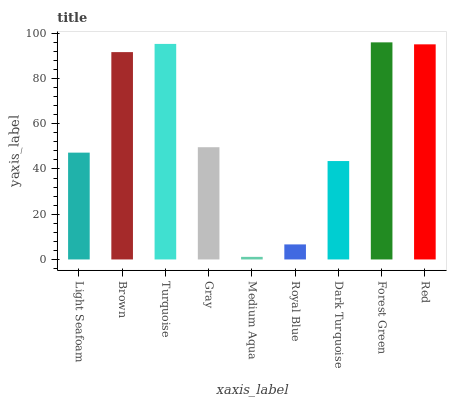Is Medium Aqua the minimum?
Answer yes or no. Yes. Is Forest Green the maximum?
Answer yes or no. Yes. Is Brown the minimum?
Answer yes or no. No. Is Brown the maximum?
Answer yes or no. No. Is Brown greater than Light Seafoam?
Answer yes or no. Yes. Is Light Seafoam less than Brown?
Answer yes or no. Yes. Is Light Seafoam greater than Brown?
Answer yes or no. No. Is Brown less than Light Seafoam?
Answer yes or no. No. Is Gray the high median?
Answer yes or no. Yes. Is Gray the low median?
Answer yes or no. Yes. Is Forest Green the high median?
Answer yes or no. No. Is Brown the low median?
Answer yes or no. No. 